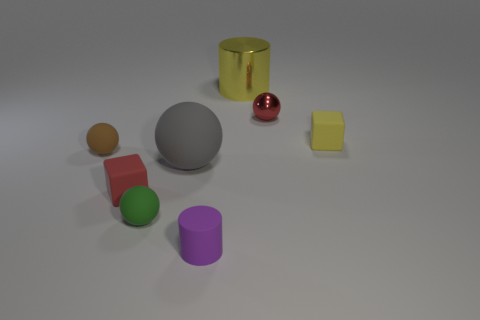Add 2 yellow cylinders. How many objects exist? 10 Subtract all cylinders. How many objects are left? 6 Add 6 small green metal objects. How many small green metal objects exist? 6 Subtract 0 blue cylinders. How many objects are left? 8 Subtract all tiny blue cylinders. Subtract all rubber balls. How many objects are left? 5 Add 2 gray matte objects. How many gray matte objects are left? 3 